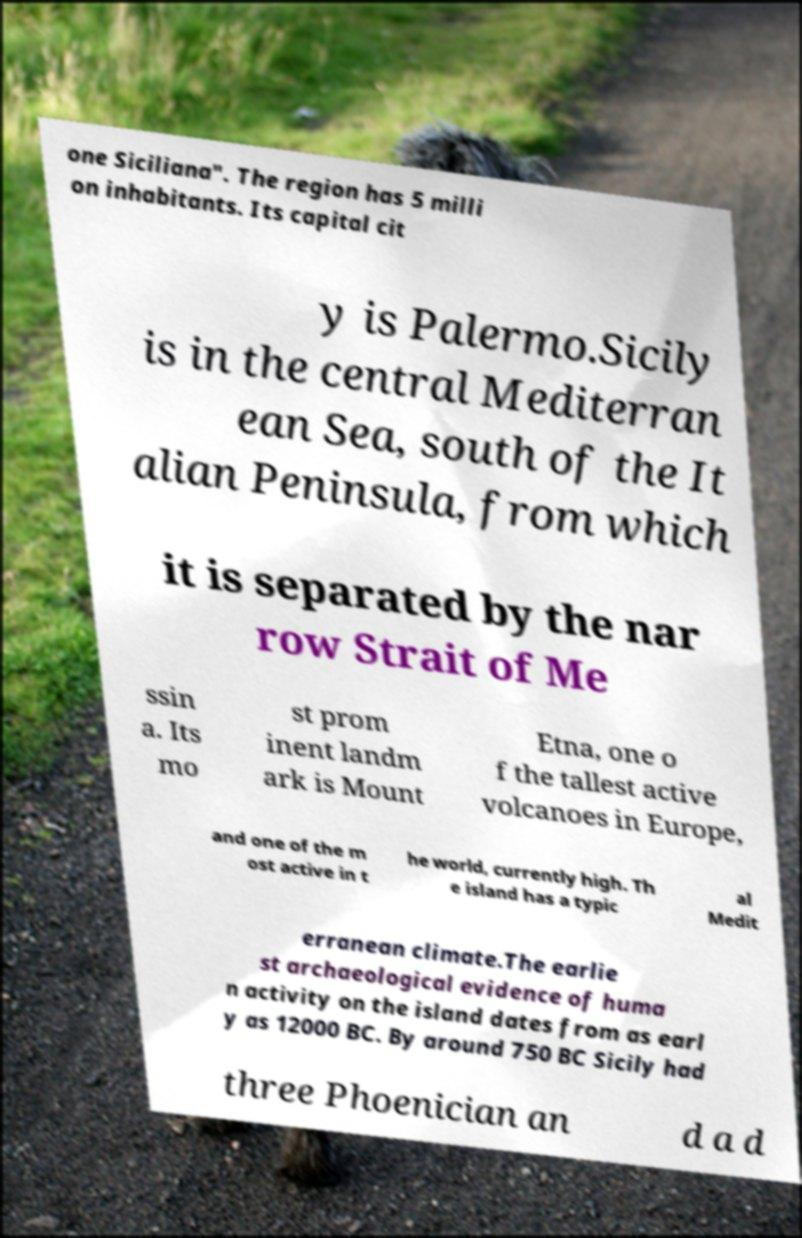Please read and relay the text visible in this image. What does it say? one Siciliana". The region has 5 milli on inhabitants. Its capital cit y is Palermo.Sicily is in the central Mediterran ean Sea, south of the It alian Peninsula, from which it is separated by the nar row Strait of Me ssin a. Its mo st prom inent landm ark is Mount Etna, one o f the tallest active volcanoes in Europe, and one of the m ost active in t he world, currently high. Th e island has a typic al Medit erranean climate.The earlie st archaeological evidence of huma n activity on the island dates from as earl y as 12000 BC. By around 750 BC Sicily had three Phoenician an d a d 